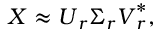<formula> <loc_0><loc_0><loc_500><loc_500>X \approx U _ { r } \Sigma _ { r } V _ { r } ^ { * } ,</formula> 